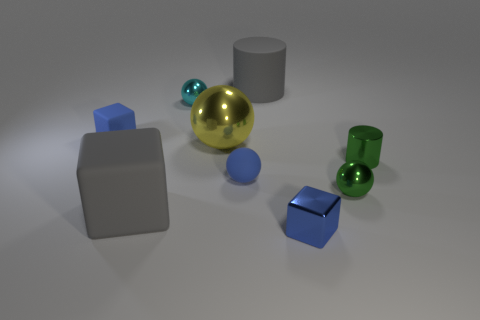Subtract all rubber blocks. How many blocks are left? 1 Subtract all cubes. How many objects are left? 6 Subtract all blue blocks. How many blocks are left? 1 Subtract all yellow cubes. Subtract all red balls. How many cubes are left? 3 Subtract all yellow blocks. How many green cylinders are left? 1 Subtract all big gray rubber cubes. Subtract all small green metallic things. How many objects are left? 6 Add 8 large cubes. How many large cubes are left? 9 Add 3 shiny cylinders. How many shiny cylinders exist? 4 Subtract 1 gray cylinders. How many objects are left? 8 Subtract 1 cylinders. How many cylinders are left? 1 